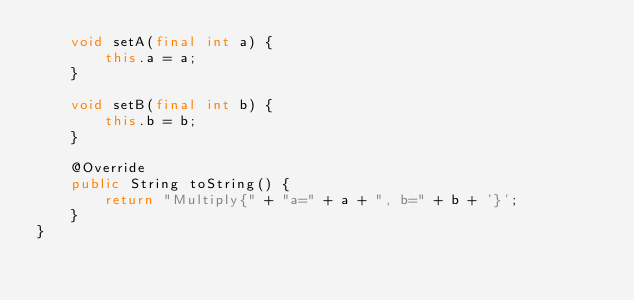<code> <loc_0><loc_0><loc_500><loc_500><_Java_>    void setA(final int a) {
        this.a = a;
    }

    void setB(final int b) {
        this.b = b;
    }

    @Override
    public String toString() {
        return "Multiply{" + "a=" + a + ", b=" + b + '}';
    }
}</code> 